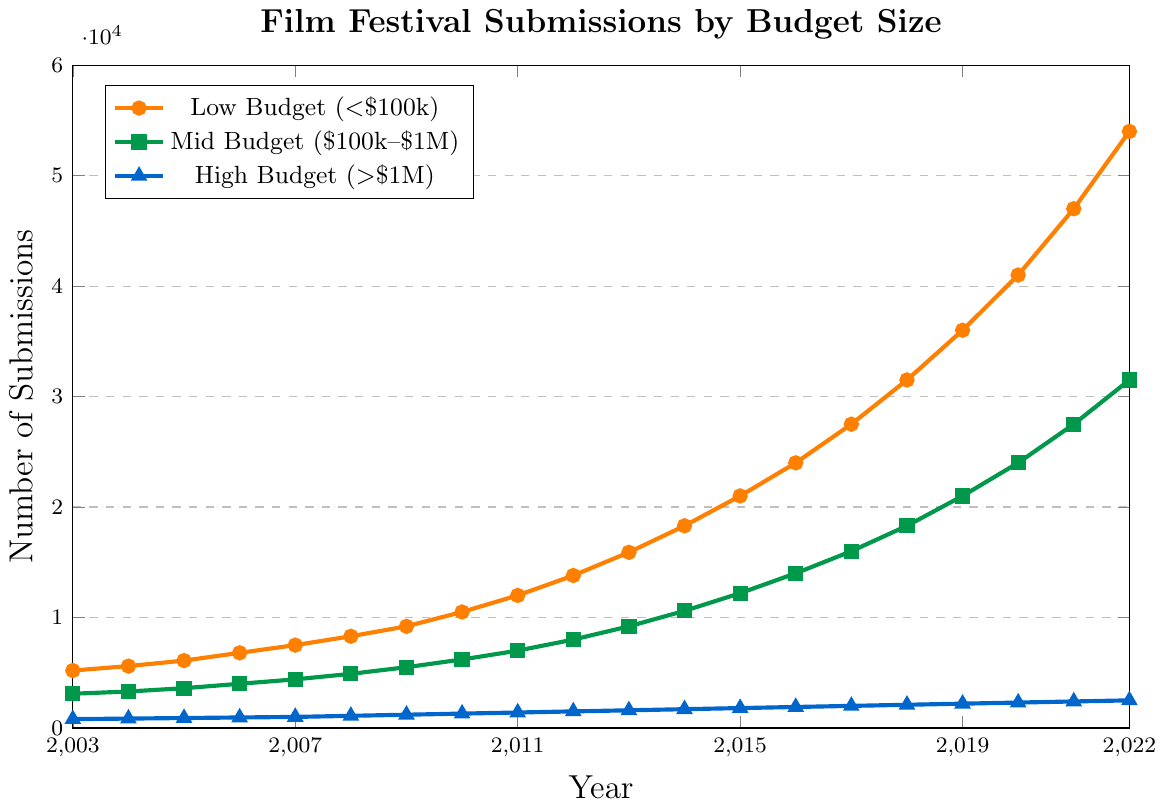What is the trend in submissions for low-budget films over the 20 years? The line representing the low-budget films in the chart shows an upward trend from 5,200 submissions in 2003 to 54,000 submissions in 2022.
Answer: Upward trend Which budget category had the highest number of submissions in 2022? In 2022, the line for low-budget films is at the highest point with 54,000 submissions, higher than both mid-budget and high-budget categories.
Answer: Low budget Between 2010 and 2015, how much did the number of submissions for mid-budget films increase? In 2010, the mid-budget submissions were 6,200, and in 2015, it was 12,200. The increase is calculated as 12,200 - 6,200 = 6,000.
Answer: 6,000 How does the growth in submissions for high-budget films compare to low-budget films from 2003 to 2022? In 2003, high-budget submissions were 800 and reached 2,500 by 2022, showing an increase of 1,700. Low-budget films started at 5,200 in 2003 and reached 54,000 in 2022, showing an increase of 48,800.
Answer: Low-budget growth is much higher What was the average number of submissions for high-budget films between 2005 and 2015? From 2005 to 2015, the values for high-budget submissions are 900 (2005), 950 (2006), 1,000 (2007), 1,100 (2008), 1,200 (2009), 1,300 (2010), 1,400 (2011), 1,500 (2012), 1,600 (2013), 1,700 (2014), and 1,800 (2015). The sum is 13,450, and the number of years is 11. Average = 13,450 / 11 = 1,222.73.
Answer: 1,222.73 In which year did mid-budget films' submissions surpass 10,000? The line representing mid-budget films shows that in 2014, the submissions were 10,600, the first year to surpass 10,000.
Answer: 2014 Between 2009 and 2020, which categories experienced an increase of more than 10,000 submissions? For low-budget films, submissions increased from 9,200 in 2009 to 41,000 in 2020, an increase of 31,800. For mid-budget films, submissions increased from 5,500 in 2009 to 24,000 in 2020, an increase of 18,500. High-budget films increased from 1,200 in 2009 to 2,300 in 2020, an increase of 1,100. So, low and mid-budget categories saw an increase of more than 10,000.
Answer: Low budget, Mid budget Visualize the submission trend for high-budget films. Do they appear to be exponential, linear, or a different pattern? The line for high-budget films shows a steady linear increase from 800 submissions in 2003 to 2,500 in 2022.
Answer: Linear 